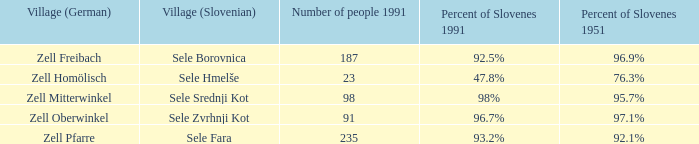Provide me with the name of all the village (German) that are part of the village (Slovenian) with sele srednji kot.  Zell Mitterwinkel. 